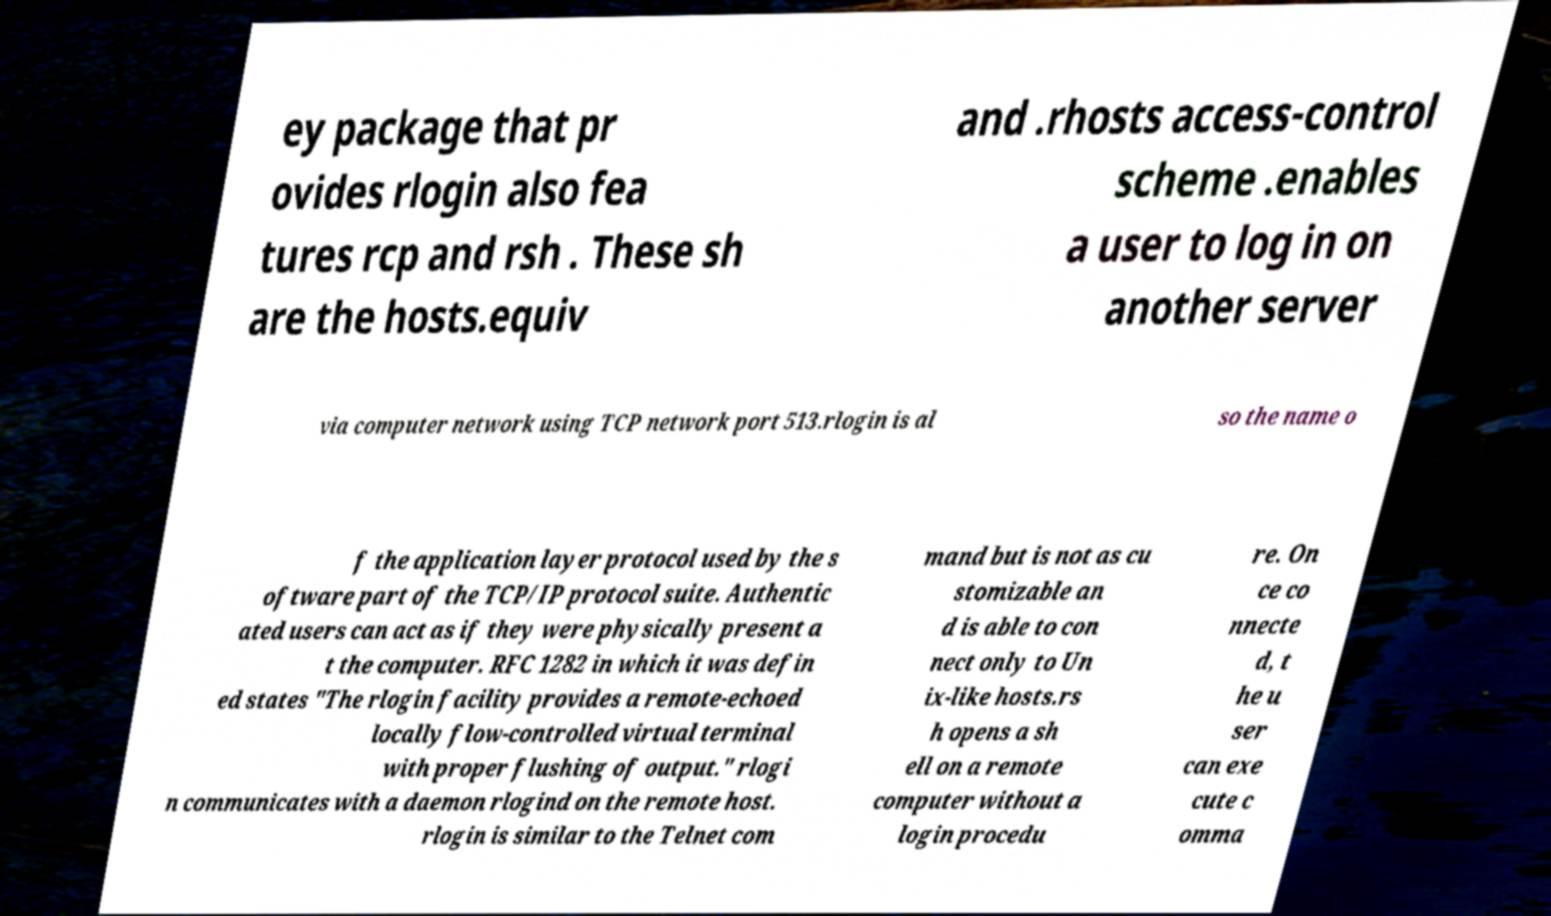There's text embedded in this image that I need extracted. Can you transcribe it verbatim? ey package that pr ovides rlogin also fea tures rcp and rsh . These sh are the hosts.equiv and .rhosts access-control scheme .enables a user to log in on another server via computer network using TCP network port 513.rlogin is al so the name o f the application layer protocol used by the s oftware part of the TCP/IP protocol suite. Authentic ated users can act as if they were physically present a t the computer. RFC 1282 in which it was defin ed states "The rlogin facility provides a remote-echoed locally flow-controlled virtual terminal with proper flushing of output." rlogi n communicates with a daemon rlogind on the remote host. rlogin is similar to the Telnet com mand but is not as cu stomizable an d is able to con nect only to Un ix-like hosts.rs h opens a sh ell on a remote computer without a login procedu re. On ce co nnecte d, t he u ser can exe cute c omma 